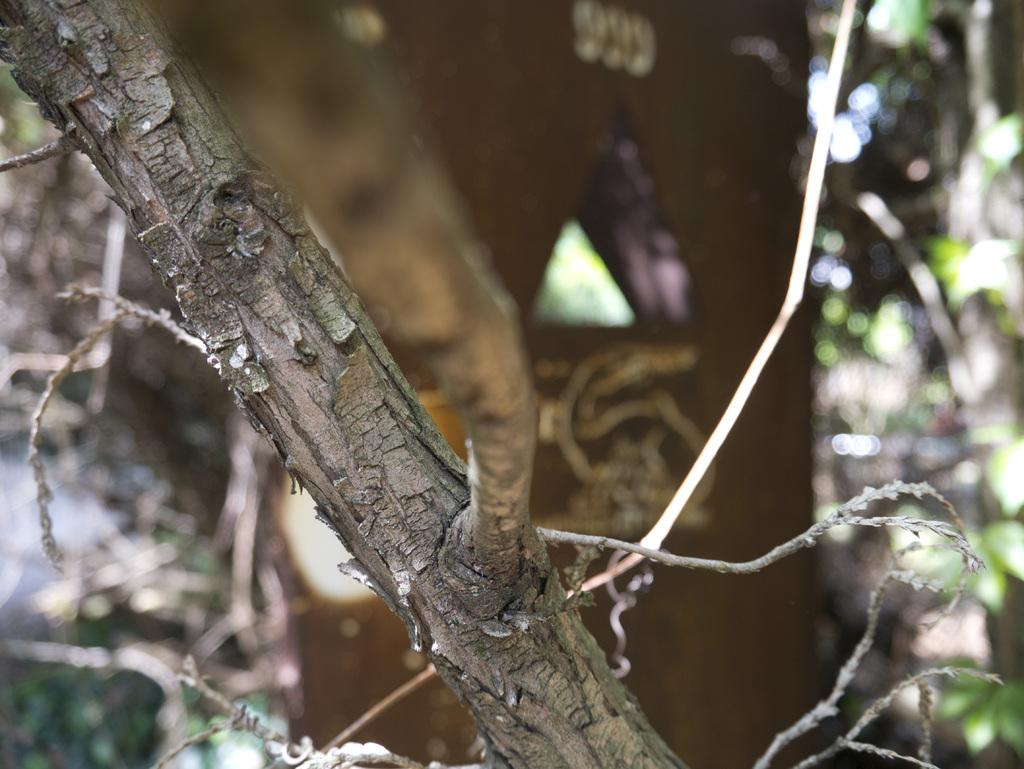What can be seen in the foreground of the image? There are tree branches in the foreground of the image. How would you describe the background of the image? The background of the image is blurred. What type of animal can be seen eating tomatoes in the image? There is no animal or tomatoes present in the image; it only features tree branches and a blurred background. 